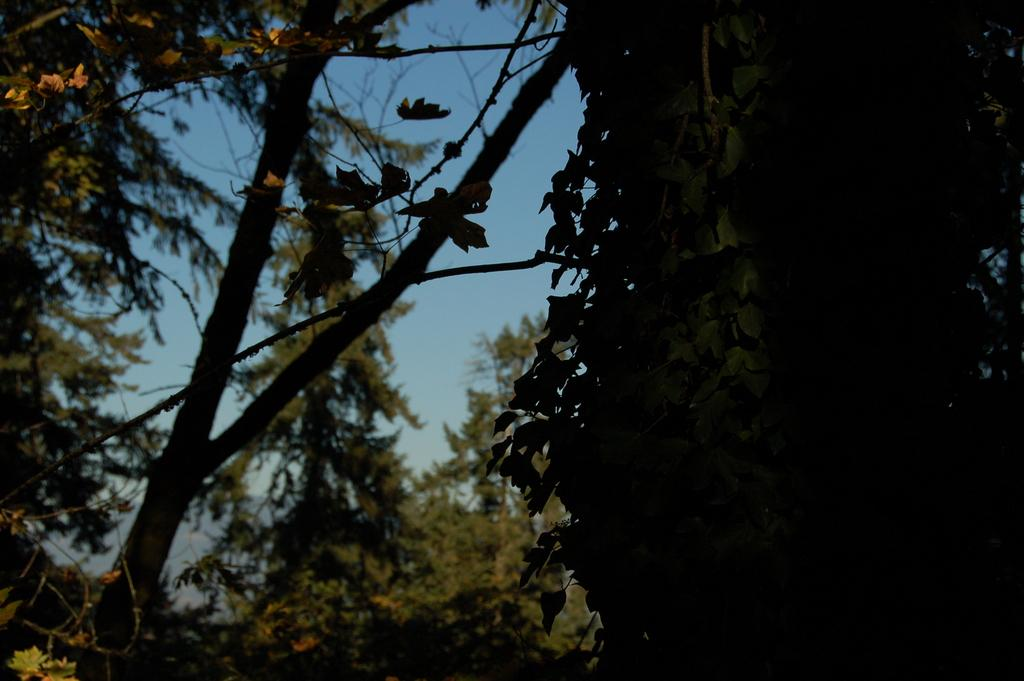What type of natural environment is depicted in the image? The image features many trees, indicating a forest or wooded area. What can be seen in the sky in the image? The sky is visible in the image, but no specific details about the sky are mentioned in the facts. What type of landscape feature is present in the image? There is a hill in the image. How many tickets are visible in the image? There is no mention of tickets in the provided facts, so it cannot be determined if any are present in the image. 